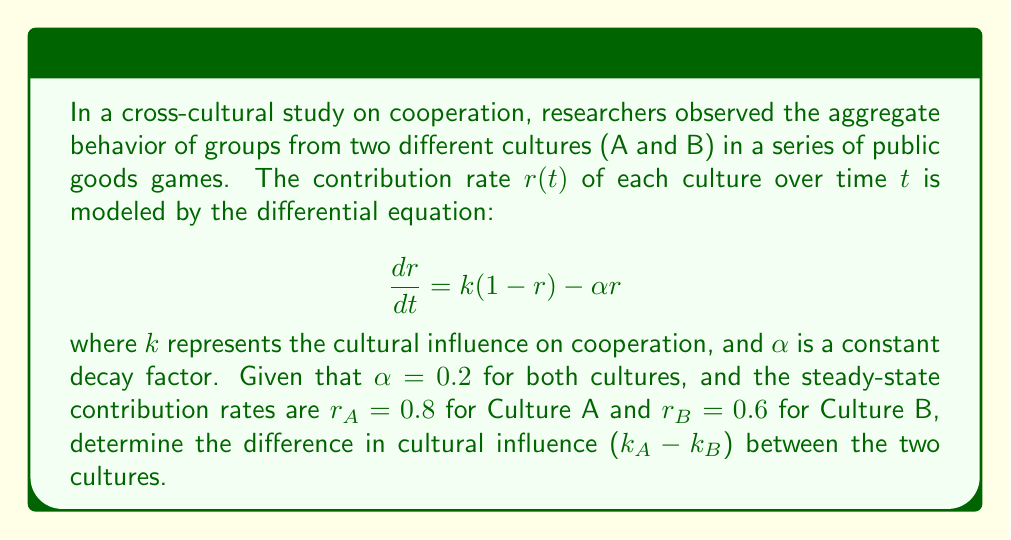Help me with this question. To solve this problem, we'll follow these steps:

1. Recall that at steady-state, $\frac{dr}{dt} = 0$. We can use this to find an equation for $k$ in terms of $r$ and $\alpha$.

2. Set the differential equation to zero:
   $$0 = k(1-r) - \alpha r$$

3. Rearrange to solve for $k$:
   $$k(1-r) = \alpha r$$
   $$k = \frac{\alpha r}{1-r}$$

4. Now, we can calculate $k_A$ and $k_B$ using the given steady-state values and $\alpha = 0.2$:

   For Culture A: $k_A = \frac{0.2 \cdot 0.8}{1-0.8} = \frac{0.16}{0.2} = 0.8$

   For Culture B: $k_B = \frac{0.2 \cdot 0.6}{1-0.6} = \frac{0.12}{0.4} = 0.3$

5. Calculate the difference in cultural influence:
   $k_A - k_B = 0.8 - 0.3 = 0.5$

Therefore, the difference in cultural influence between Culture A and Culture B is 0.5.
Answer: 0.5 